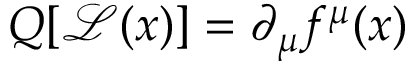<formula> <loc_0><loc_0><loc_500><loc_500>Q [ { \mathcal { L } } ( x ) ] = \partial _ { \mu } f ^ { \mu } ( x )</formula> 